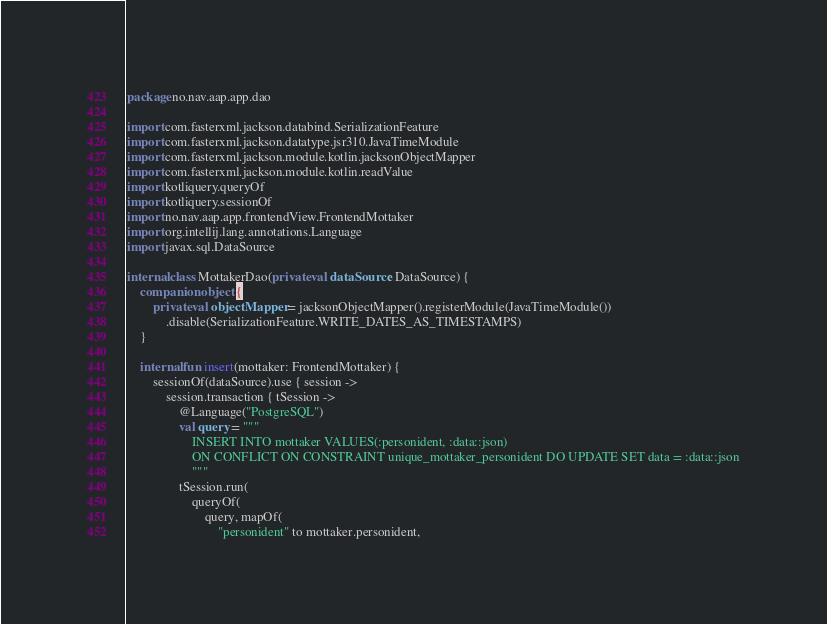<code> <loc_0><loc_0><loc_500><loc_500><_Kotlin_>package no.nav.aap.app.dao

import com.fasterxml.jackson.databind.SerializationFeature
import com.fasterxml.jackson.datatype.jsr310.JavaTimeModule
import com.fasterxml.jackson.module.kotlin.jacksonObjectMapper
import com.fasterxml.jackson.module.kotlin.readValue
import kotliquery.queryOf
import kotliquery.sessionOf
import no.nav.aap.app.frontendView.FrontendMottaker
import org.intellij.lang.annotations.Language
import javax.sql.DataSource

internal class MottakerDao(private val dataSource: DataSource) {
    companion object {
        private val objectMapper = jacksonObjectMapper().registerModule(JavaTimeModule())
            .disable(SerializationFeature.WRITE_DATES_AS_TIMESTAMPS)
    }

    internal fun insert(mottaker: FrontendMottaker) {
        sessionOf(dataSource).use { session ->
            session.transaction { tSession ->
                @Language("PostgreSQL")
                val query = """
                    INSERT INTO mottaker VALUES(:personident, :data::json)
                    ON CONFLICT ON CONSTRAINT unique_mottaker_personident DO UPDATE SET data = :data::json
                    """
                tSession.run(
                    queryOf(
                        query, mapOf(
                            "personident" to mottaker.personident,</code> 